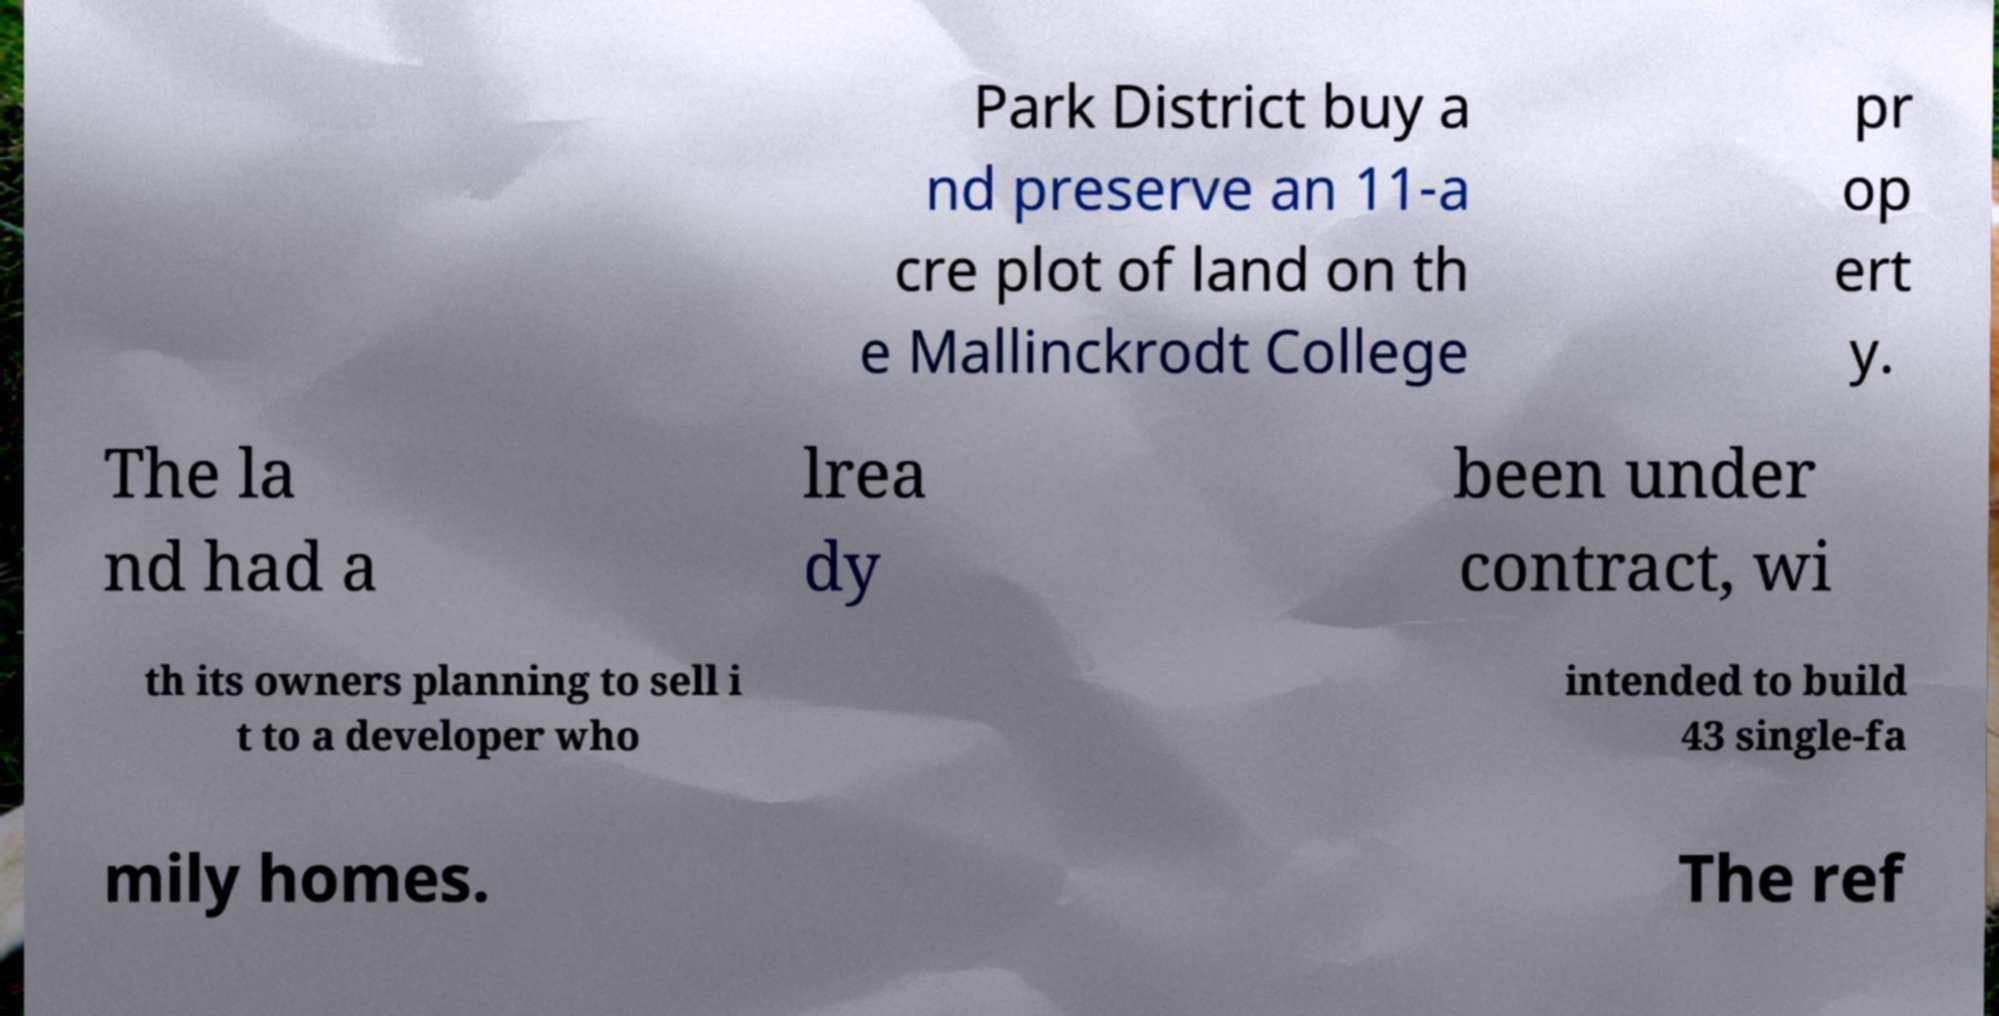Can you accurately transcribe the text from the provided image for me? Park District buy a nd preserve an 11-a cre plot of land on th e Mallinckrodt College pr op ert y. The la nd had a lrea dy been under contract, wi th its owners planning to sell i t to a developer who intended to build 43 single-fa mily homes. The ref 